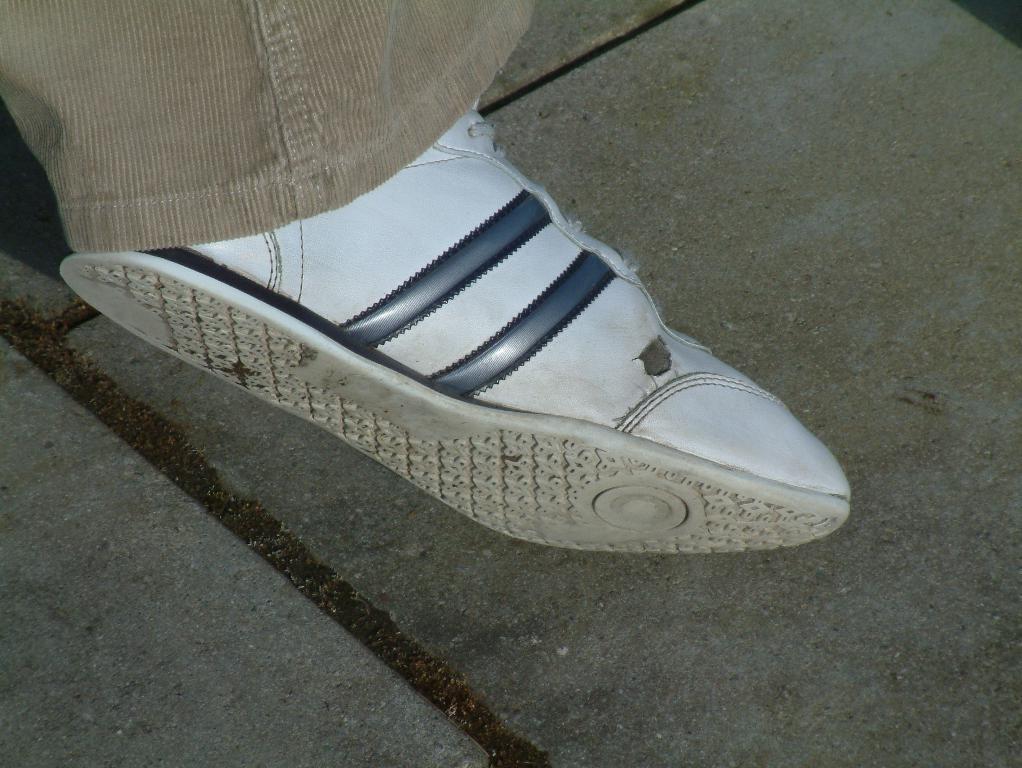In one or two sentences, can you explain what this image depicts? In this picture we can see a white shoe and a cloth. Behind the show there are tiles. 